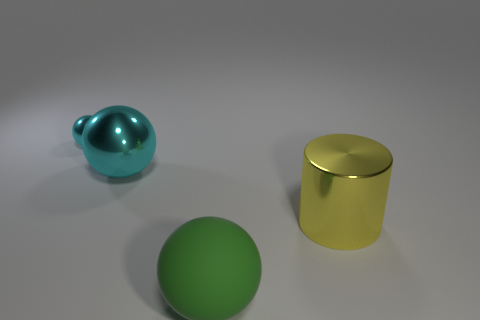Subtract all metallic balls. How many balls are left? 1 Add 3 small spheres. How many objects exist? 7 Subtract all cylinders. How many objects are left? 3 Subtract all large yellow metallic things. Subtract all tiny purple metallic cylinders. How many objects are left? 3 Add 2 big yellow objects. How many big yellow objects are left? 3 Add 3 red rubber cylinders. How many red rubber cylinders exist? 3 Subtract 1 yellow cylinders. How many objects are left? 3 